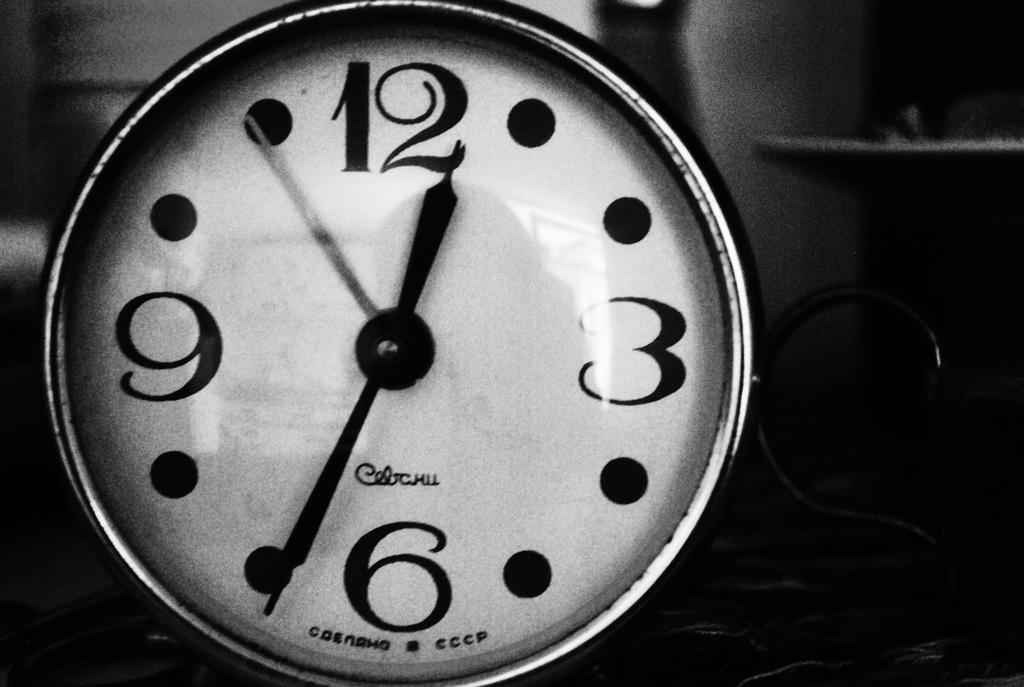<image>
Present a compact description of the photo's key features. A sign with CCCP on the bottom of it and only four numbers. 